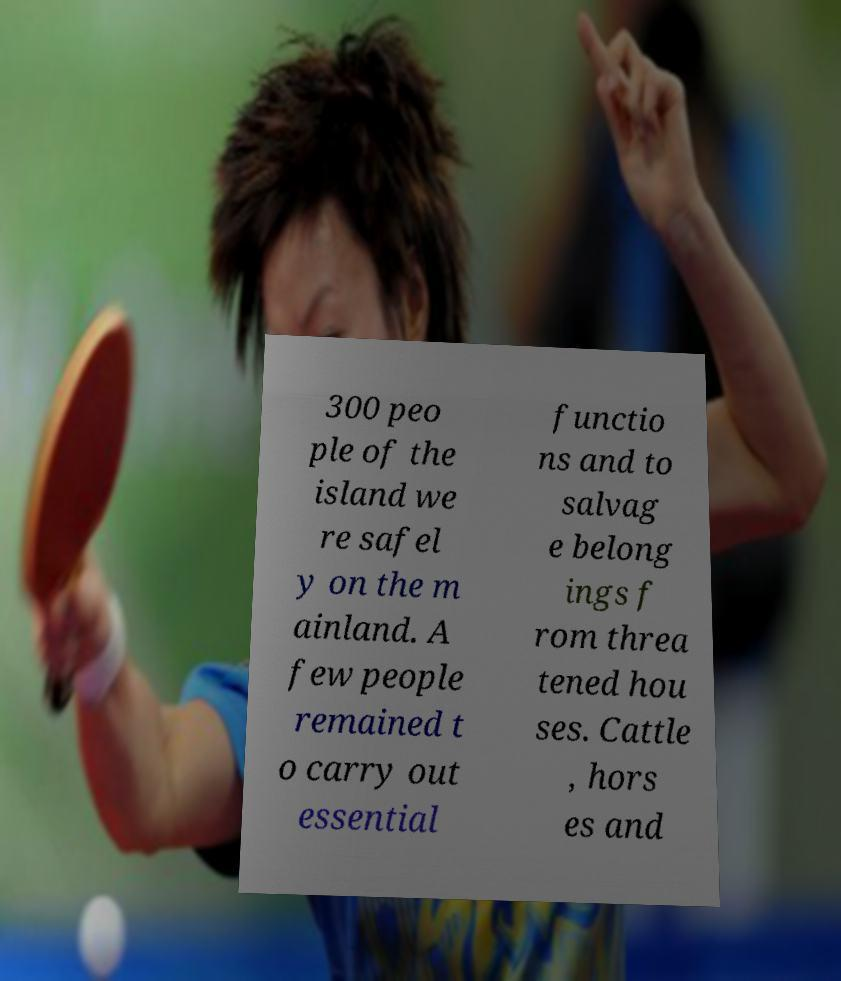Please identify and transcribe the text found in this image. 300 peo ple of the island we re safel y on the m ainland. A few people remained t o carry out essential functio ns and to salvag e belong ings f rom threa tened hou ses. Cattle , hors es and 